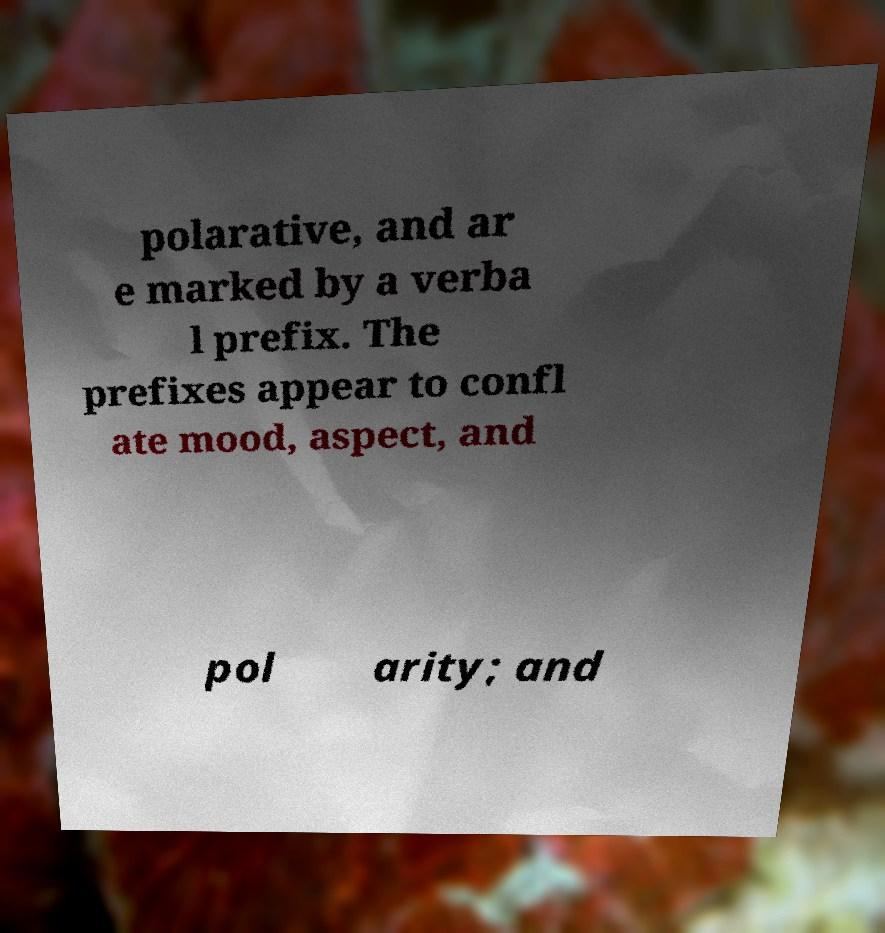There's text embedded in this image that I need extracted. Can you transcribe it verbatim? polarative, and ar e marked by a verba l prefix. The prefixes appear to confl ate mood, aspect, and pol arity; and 